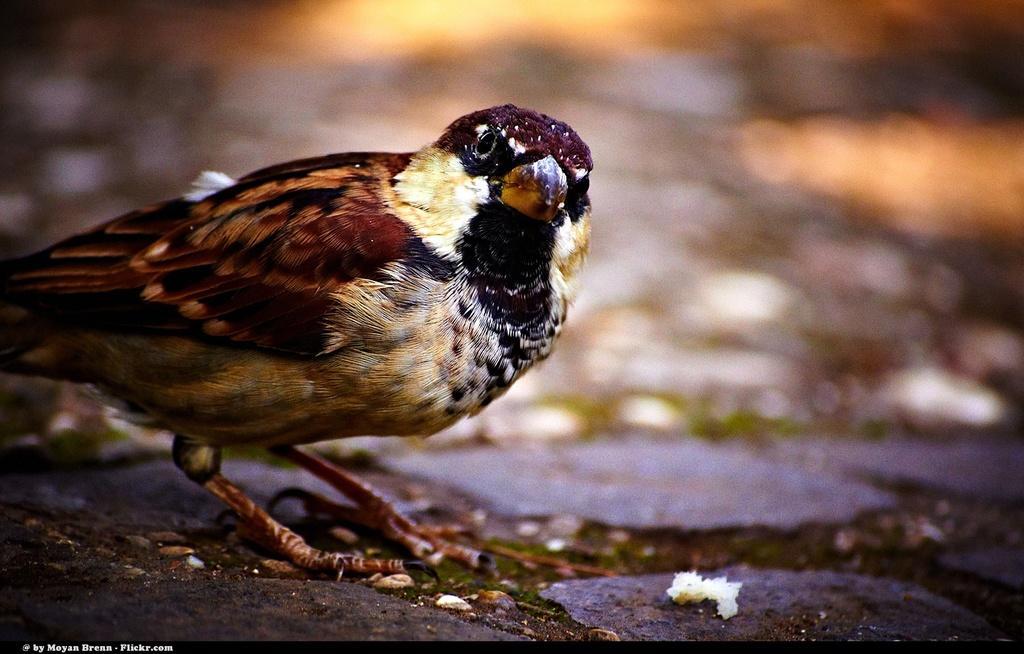Can you describe this image briefly? In the foreground of this image, there is a bird and a white substance is on the ground and the background image is blurred. 